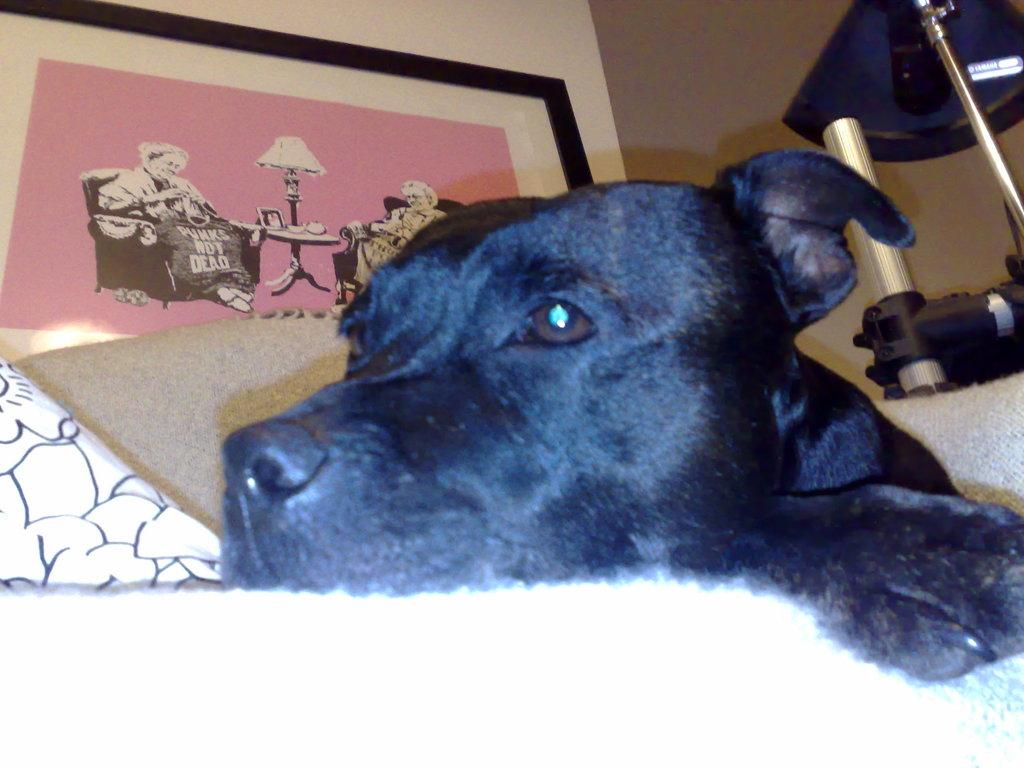What type of animal is in the image? There is a black dog in the image. What is the dog doing in the image? The dog is sleeping. Where is the dog located in the image? The dog is on a bed. What type of tax does the goose pay in the image? There is no goose or tax mentioned in the image. The image only features a black dog that is sleeping on a bed. 